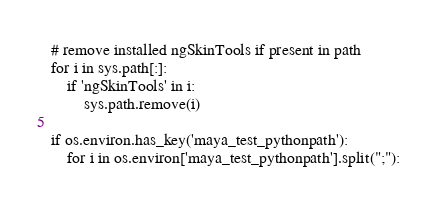<code> <loc_0><loc_0><loc_500><loc_500><_Python_># remove installed ngSkinTools if present in path
for i in sys.path[:]:
    if 'ngSkinTools' in i:
        sys.path.remove(i)

if os.environ.has_key('maya_test_pythonpath'):
    for i in os.environ['maya_test_pythonpath'].split(";"):</code> 